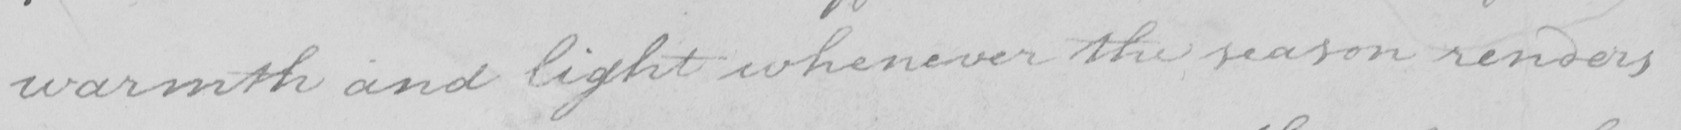Please transcribe the handwritten text in this image. warmth and light whenever the reason renders 